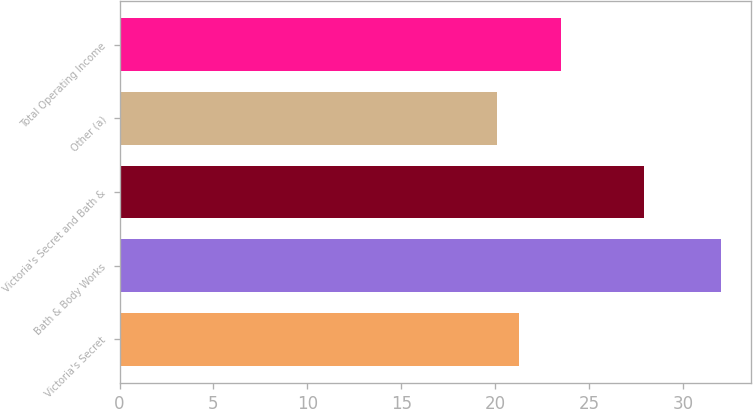Convert chart to OTSL. <chart><loc_0><loc_0><loc_500><loc_500><bar_chart><fcel>Victoria's Secret<fcel>Bath & Body Works<fcel>Victoria's Secret and Bath &<fcel>Other (a)<fcel>Total Operating Income<nl><fcel>21.29<fcel>32<fcel>27.9<fcel>20.1<fcel>23.5<nl></chart> 